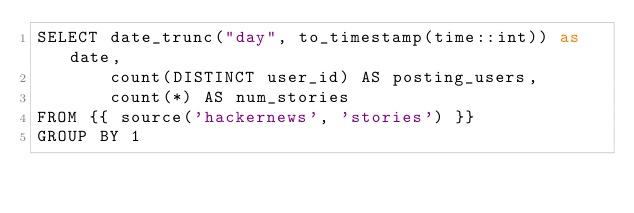<code> <loc_0><loc_0><loc_500><loc_500><_SQL_>SELECT date_trunc("day", to_timestamp(time::int)) as date,
       count(DISTINCT user_id) AS posting_users,
       count(*) AS num_stories
FROM {{ source('hackernews', 'stories') }}
GROUP BY 1
</code> 